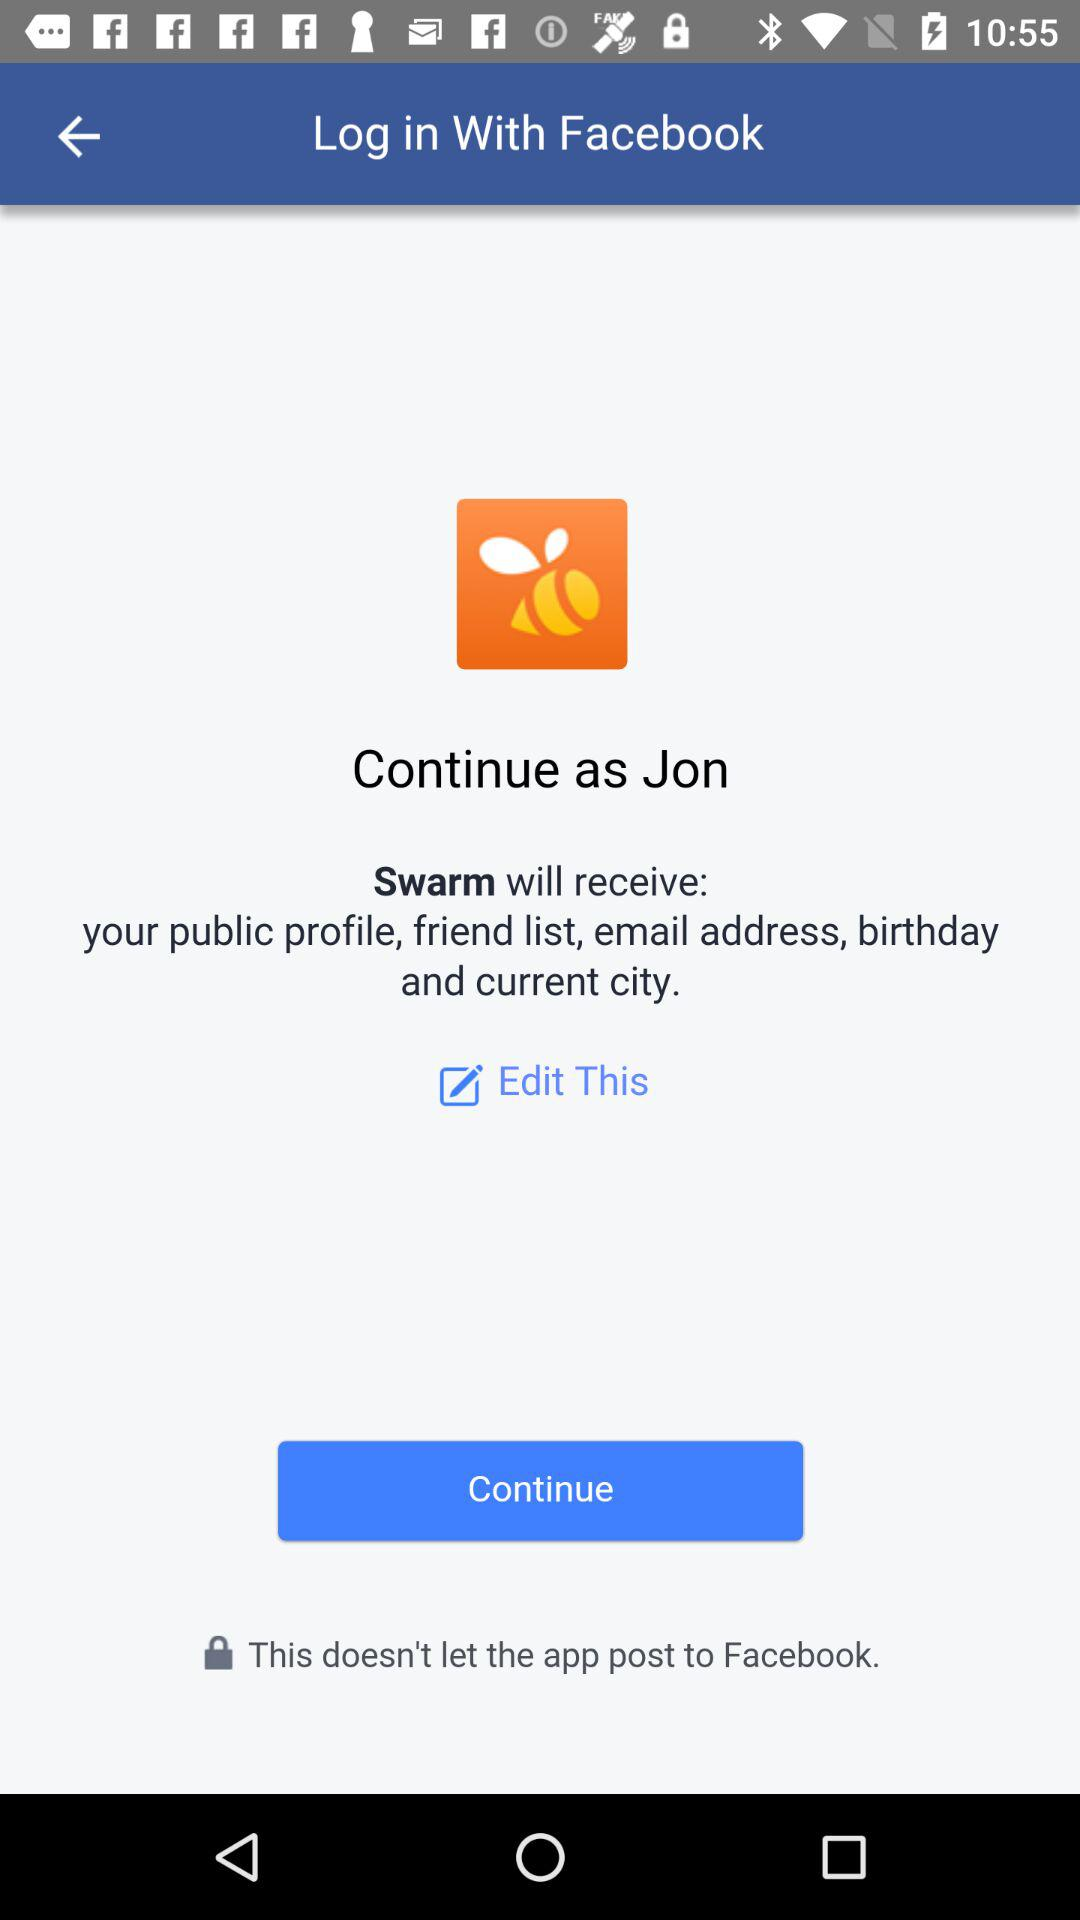What application can be used to log in? The application is "Facebook". 